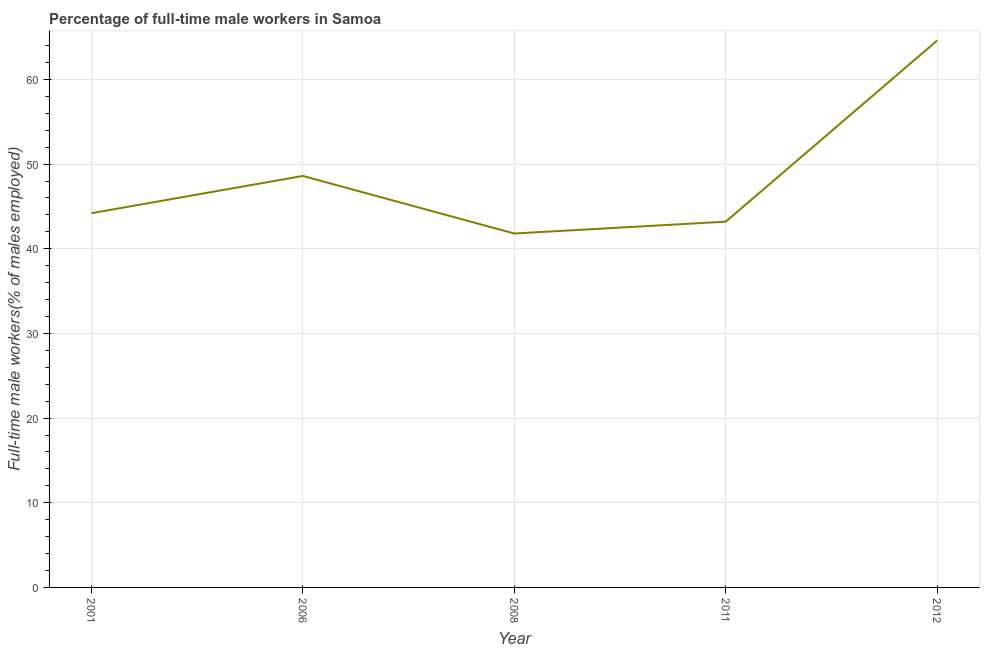What is the percentage of full-time male workers in 2006?
Make the answer very short. 48.6. Across all years, what is the maximum percentage of full-time male workers?
Provide a short and direct response. 64.6. Across all years, what is the minimum percentage of full-time male workers?
Keep it short and to the point. 41.8. In which year was the percentage of full-time male workers maximum?
Give a very brief answer. 2012. What is the sum of the percentage of full-time male workers?
Your response must be concise. 242.4. What is the average percentage of full-time male workers per year?
Offer a terse response. 48.48. What is the median percentage of full-time male workers?
Make the answer very short. 44.2. What is the ratio of the percentage of full-time male workers in 2008 to that in 2011?
Ensure brevity in your answer.  0.97. Is the percentage of full-time male workers in 2006 less than that in 2012?
Ensure brevity in your answer.  Yes. What is the difference between the highest and the second highest percentage of full-time male workers?
Ensure brevity in your answer.  16. Is the sum of the percentage of full-time male workers in 2001 and 2008 greater than the maximum percentage of full-time male workers across all years?
Keep it short and to the point. Yes. What is the difference between the highest and the lowest percentage of full-time male workers?
Offer a very short reply. 22.8. Does the percentage of full-time male workers monotonically increase over the years?
Provide a succinct answer. No. Does the graph contain any zero values?
Provide a succinct answer. No. Does the graph contain grids?
Give a very brief answer. Yes. What is the title of the graph?
Give a very brief answer. Percentage of full-time male workers in Samoa. What is the label or title of the Y-axis?
Make the answer very short. Full-time male workers(% of males employed). What is the Full-time male workers(% of males employed) of 2001?
Make the answer very short. 44.2. What is the Full-time male workers(% of males employed) of 2006?
Offer a terse response. 48.6. What is the Full-time male workers(% of males employed) of 2008?
Offer a terse response. 41.8. What is the Full-time male workers(% of males employed) in 2011?
Give a very brief answer. 43.2. What is the Full-time male workers(% of males employed) in 2012?
Keep it short and to the point. 64.6. What is the difference between the Full-time male workers(% of males employed) in 2001 and 2006?
Offer a very short reply. -4.4. What is the difference between the Full-time male workers(% of males employed) in 2001 and 2012?
Your answer should be very brief. -20.4. What is the difference between the Full-time male workers(% of males employed) in 2006 and 2012?
Provide a succinct answer. -16. What is the difference between the Full-time male workers(% of males employed) in 2008 and 2012?
Provide a short and direct response. -22.8. What is the difference between the Full-time male workers(% of males employed) in 2011 and 2012?
Provide a short and direct response. -21.4. What is the ratio of the Full-time male workers(% of males employed) in 2001 to that in 2006?
Provide a succinct answer. 0.91. What is the ratio of the Full-time male workers(% of males employed) in 2001 to that in 2008?
Your answer should be very brief. 1.06. What is the ratio of the Full-time male workers(% of males employed) in 2001 to that in 2012?
Your answer should be compact. 0.68. What is the ratio of the Full-time male workers(% of males employed) in 2006 to that in 2008?
Make the answer very short. 1.16. What is the ratio of the Full-time male workers(% of males employed) in 2006 to that in 2011?
Your answer should be compact. 1.12. What is the ratio of the Full-time male workers(% of males employed) in 2006 to that in 2012?
Offer a terse response. 0.75. What is the ratio of the Full-time male workers(% of males employed) in 2008 to that in 2012?
Make the answer very short. 0.65. What is the ratio of the Full-time male workers(% of males employed) in 2011 to that in 2012?
Ensure brevity in your answer.  0.67. 